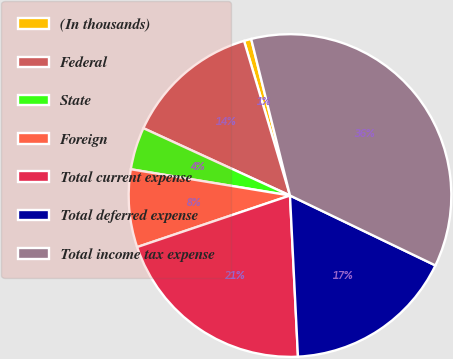Convert chart. <chart><loc_0><loc_0><loc_500><loc_500><pie_chart><fcel>(In thousands)<fcel>Federal<fcel>State<fcel>Foreign<fcel>Total current expense<fcel>Total deferred expense<fcel>Total income tax expense<nl><fcel>0.73%<fcel>13.55%<fcel>4.25%<fcel>7.78%<fcel>20.61%<fcel>17.08%<fcel>36.0%<nl></chart> 